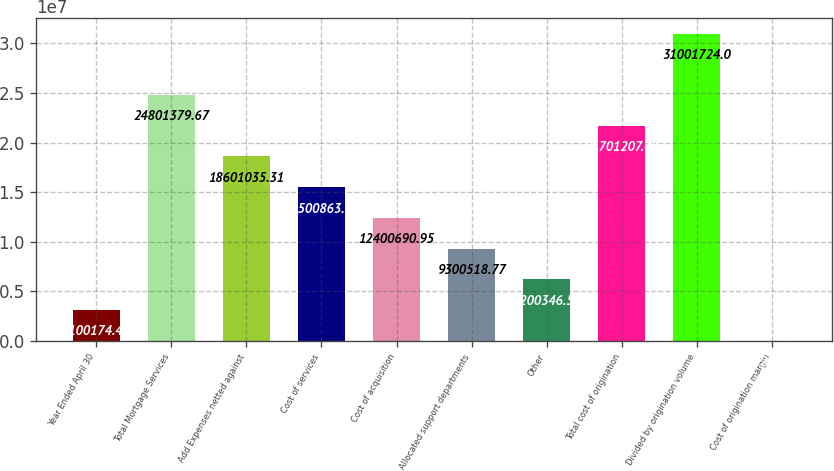<chart> <loc_0><loc_0><loc_500><loc_500><bar_chart><fcel>Year Ended April 30<fcel>Total Mortgage Services<fcel>Add Expenses netted against<fcel>Cost of services<fcel>Cost of acquisition<fcel>Allocated support departments<fcel>Other<fcel>Total cost of origination<fcel>Divided by origination volume<fcel>Cost of origination margin<nl><fcel>3.10017e+06<fcel>2.48014e+07<fcel>1.8601e+07<fcel>1.55009e+07<fcel>1.24007e+07<fcel>9.30052e+06<fcel>6.20035e+06<fcel>2.17012e+07<fcel>3.10017e+07<fcel>2.23<nl></chart> 